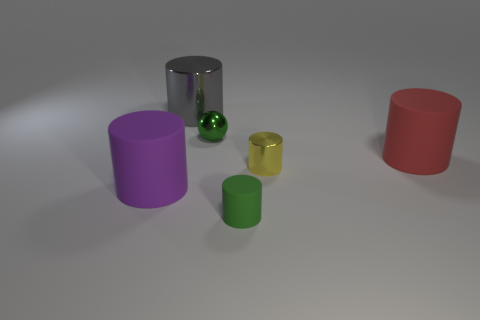Is there anything else that is the same shape as the small green metallic thing?
Your answer should be compact. No. Is the number of yellow things behind the metal ball the same as the number of yellow rubber objects?
Keep it short and to the point. Yes. How many things are both in front of the green sphere and to the right of the large shiny cylinder?
Provide a succinct answer. 3. The other metallic thing that is the same shape as the small yellow object is what size?
Provide a short and direct response. Large. What number of green cylinders have the same material as the big purple cylinder?
Keep it short and to the point. 1. Are there fewer big cylinders behind the small metal sphere than small green shiny balls?
Provide a short and direct response. No. What number of big rubber objects are there?
Offer a terse response. 2. How many other tiny things are the same color as the small matte thing?
Offer a very short reply. 1. Is the shape of the big purple rubber thing the same as the yellow metal thing?
Make the answer very short. Yes. There is a green object left of the small green thing right of the small green shiny ball; how big is it?
Offer a very short reply. Small. 